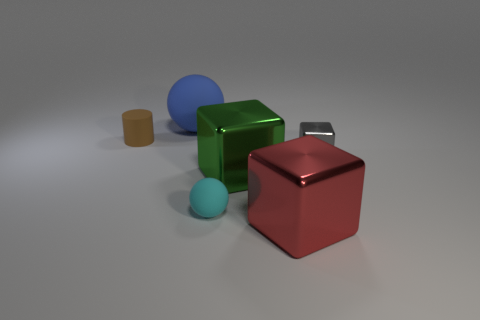What number of red shiny objects have the same shape as the big green metal thing?
Offer a terse response. 1. There is a sphere that is the same size as the cylinder; what material is it?
Make the answer very short. Rubber. What size is the matte sphere behind the big green block in front of the block that is behind the large green shiny block?
Offer a terse response. Large. There is a big thing that is behind the brown cylinder; is its color the same as the small matte object in front of the gray thing?
Provide a succinct answer. No. What number of blue things are either tiny cubes or rubber cylinders?
Give a very brief answer. 0. How many brown objects are the same size as the cyan rubber sphere?
Give a very brief answer. 1. Is the material of the tiny object in front of the large green thing the same as the large green thing?
Keep it short and to the point. No. There is a sphere behind the big green metallic block; is there a big blue matte object that is left of it?
Your response must be concise. No. There is a small object that is the same shape as the big blue object; what material is it?
Offer a very short reply. Rubber. Are there more small cyan objects behind the big blue object than brown objects in front of the large green shiny object?
Your answer should be compact. No. 